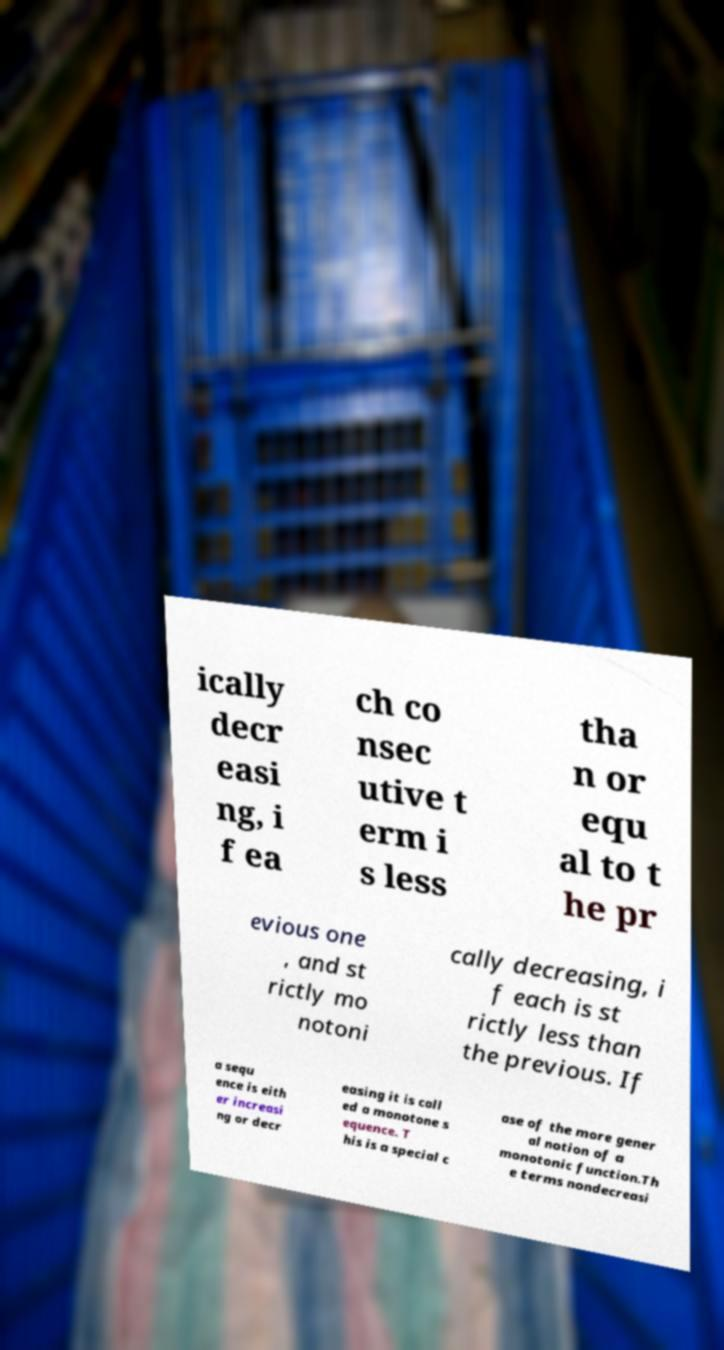Could you assist in decoding the text presented in this image and type it out clearly? ically decr easi ng, i f ea ch co nsec utive t erm i s less tha n or equ al to t he pr evious one , and st rictly mo notoni cally decreasing, i f each is st rictly less than the previous. If a sequ ence is eith er increasi ng or decr easing it is call ed a monotone s equence. T his is a special c ase of the more gener al notion of a monotonic function.Th e terms nondecreasi 